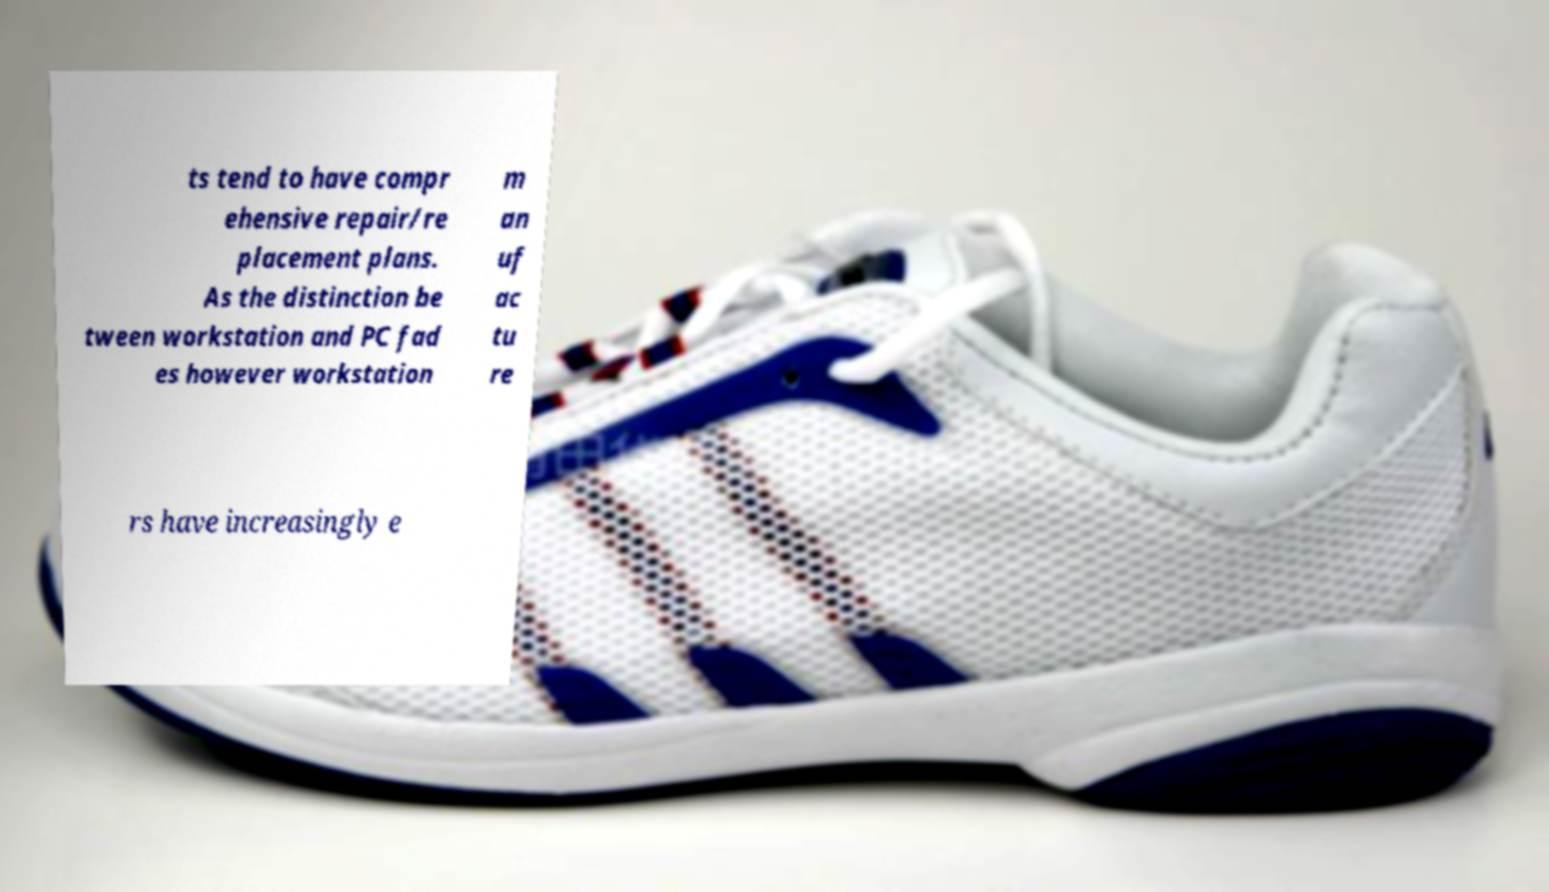Can you accurately transcribe the text from the provided image for me? ts tend to have compr ehensive repair/re placement plans. As the distinction be tween workstation and PC fad es however workstation m an uf ac tu re rs have increasingly e 